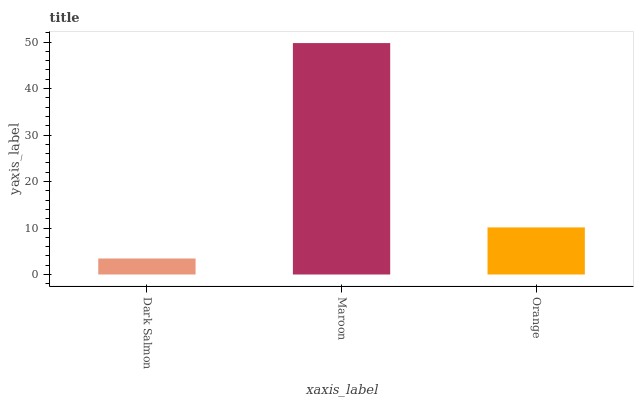Is Dark Salmon the minimum?
Answer yes or no. Yes. Is Maroon the maximum?
Answer yes or no. Yes. Is Orange the minimum?
Answer yes or no. No. Is Orange the maximum?
Answer yes or no. No. Is Maroon greater than Orange?
Answer yes or no. Yes. Is Orange less than Maroon?
Answer yes or no. Yes. Is Orange greater than Maroon?
Answer yes or no. No. Is Maroon less than Orange?
Answer yes or no. No. Is Orange the high median?
Answer yes or no. Yes. Is Orange the low median?
Answer yes or no. Yes. Is Dark Salmon the high median?
Answer yes or no. No. Is Maroon the low median?
Answer yes or no. No. 